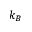<formula> <loc_0><loc_0><loc_500><loc_500>k _ { B }</formula> 